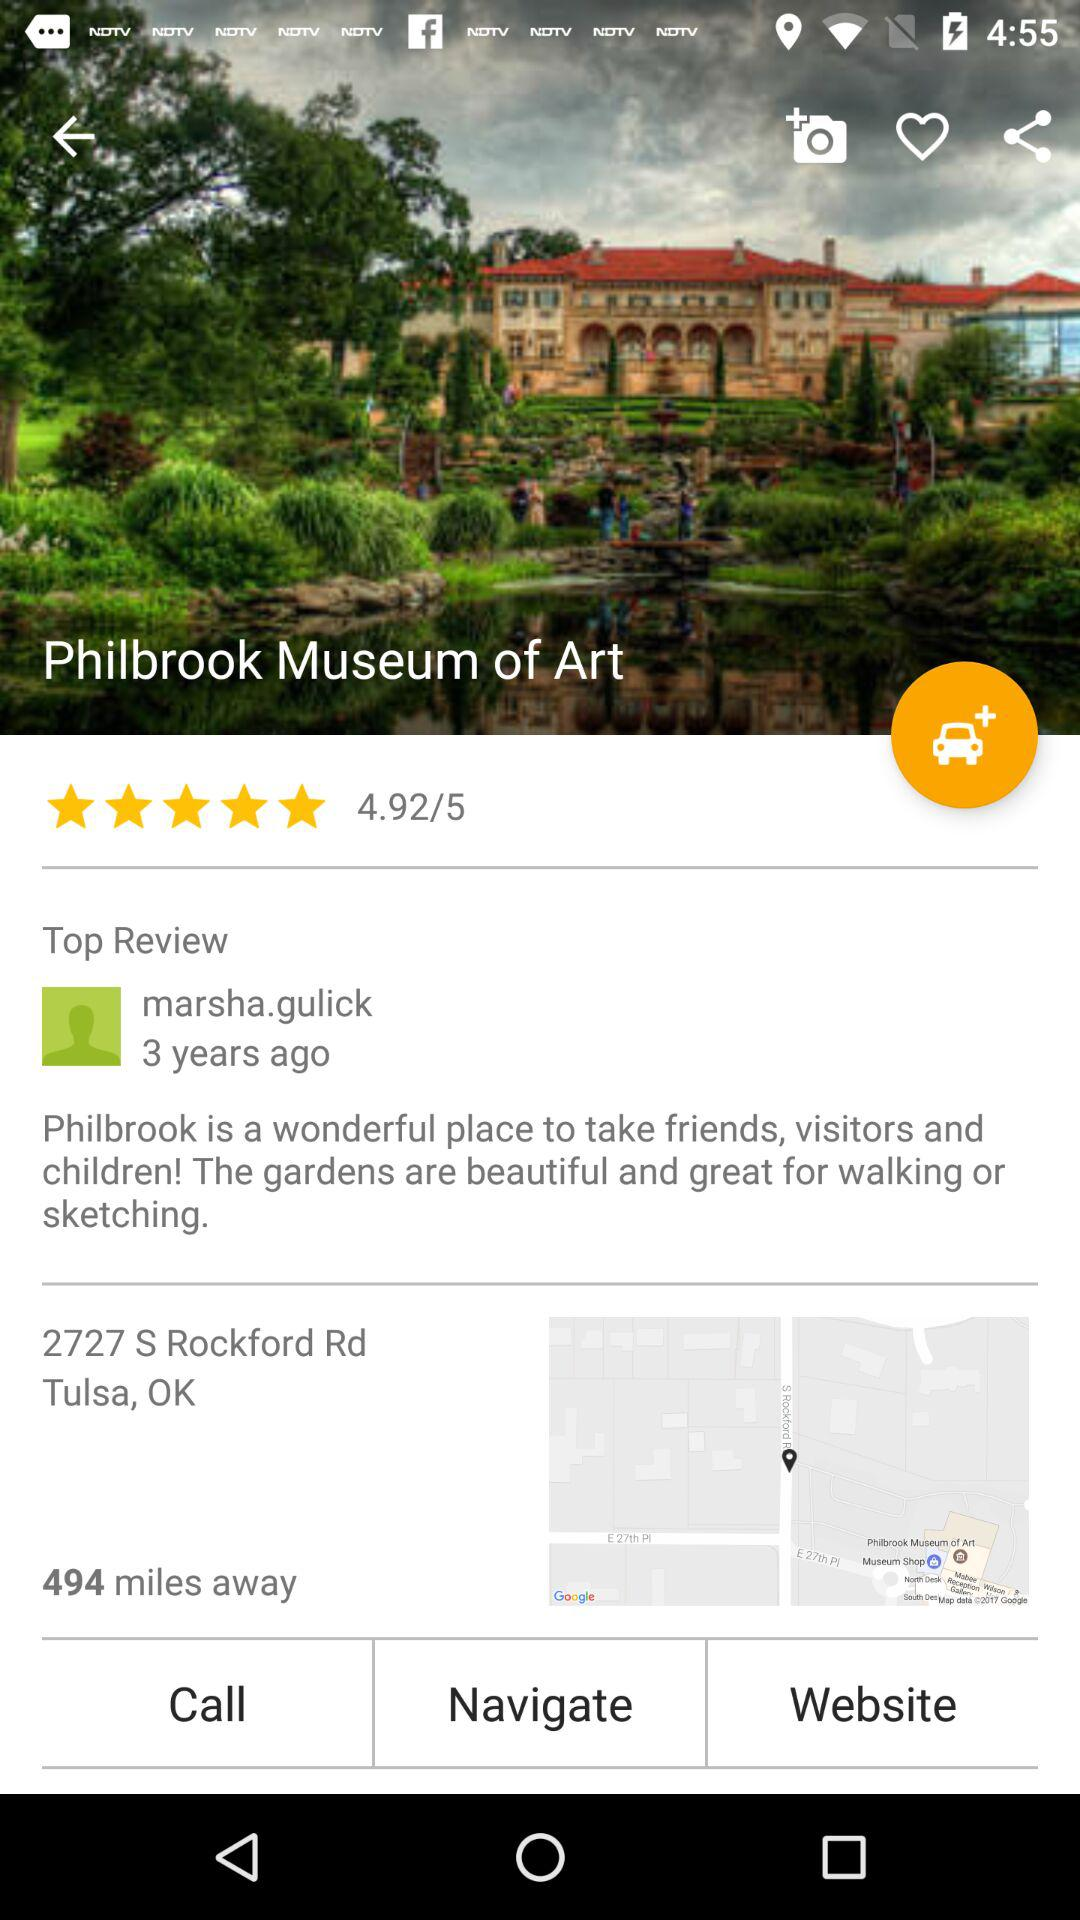What is the username of the reviewer? The username of the reviewer is "marsha.gulick". 